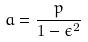<formula> <loc_0><loc_0><loc_500><loc_500>a = \frac { p } { 1 - \epsilon ^ { 2 } }</formula> 